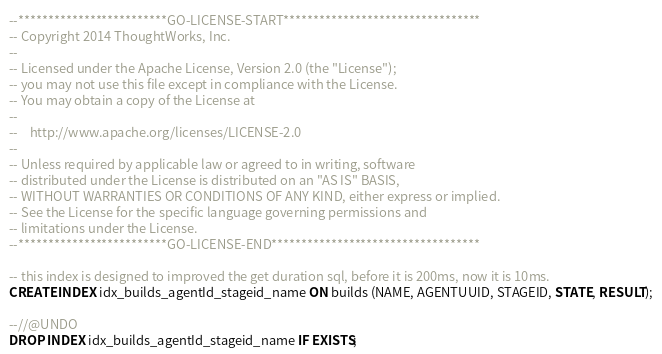Convert code to text. <code><loc_0><loc_0><loc_500><loc_500><_SQL_>--*************************GO-LICENSE-START*********************************
-- Copyright 2014 ThoughtWorks, Inc.
--
-- Licensed under the Apache License, Version 2.0 (the "License");
-- you may not use this file except in compliance with the License.
-- You may obtain a copy of the License at
--
--    http://www.apache.org/licenses/LICENSE-2.0
--
-- Unless required by applicable law or agreed to in writing, software
-- distributed under the License is distributed on an "AS IS" BASIS,
-- WITHOUT WARRANTIES OR CONDITIONS OF ANY KIND, either express or implied.
-- See the License for the specific language governing permissions and
-- limitations under the License.
--*************************GO-LICENSE-END***********************************

-- this index is designed to improved the get duration sql, before it is 200ms, now it is 10ms.
CREATE INDEX idx_builds_agentId_stageid_name ON builds (NAME, AGENTUUID, STAGEID, STATE, RESULT);

--//@UNDO
DROP INDEX idx_builds_agentId_stageid_name IF EXISTS;
</code> 